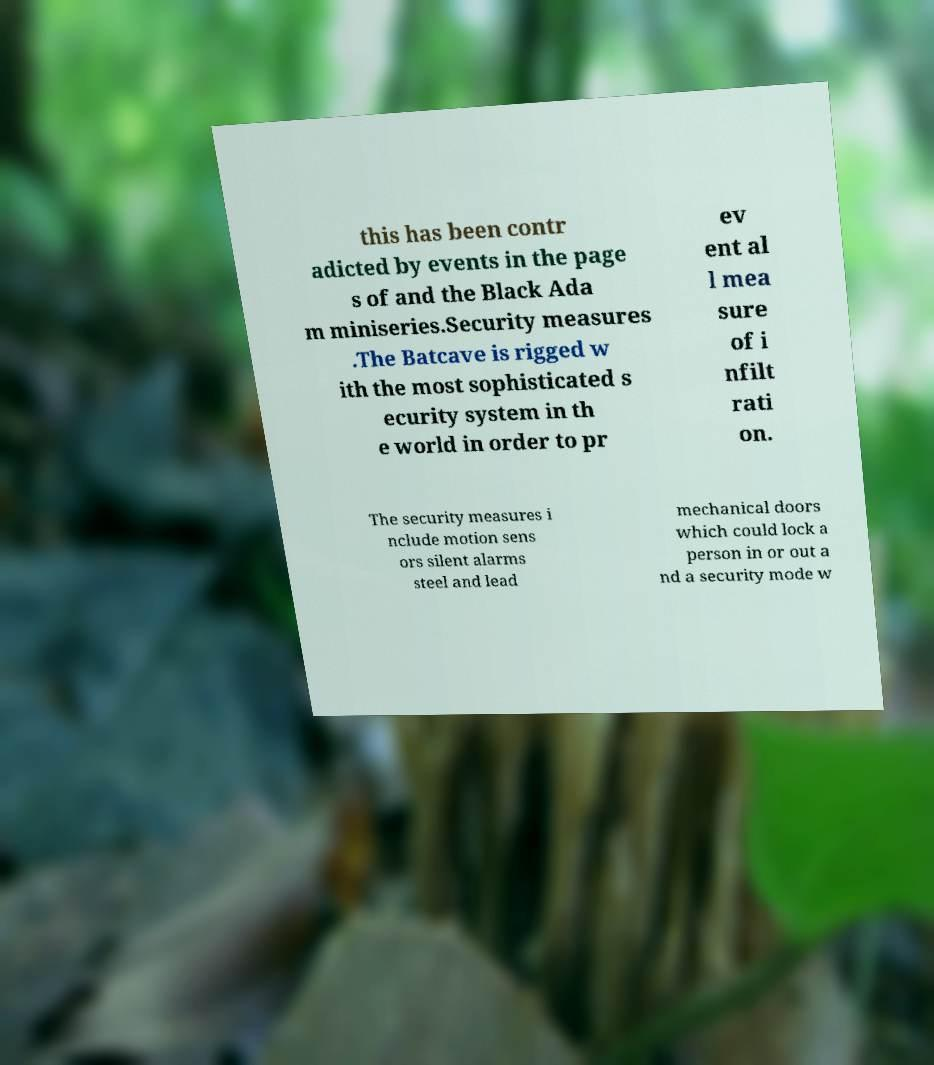For documentation purposes, I need the text within this image transcribed. Could you provide that? this has been contr adicted by events in the page s of and the Black Ada m miniseries.Security measures .The Batcave is rigged w ith the most sophisticated s ecurity system in th e world in order to pr ev ent al l mea sure of i nfilt rati on. The security measures i nclude motion sens ors silent alarms steel and lead mechanical doors which could lock a person in or out a nd a security mode w 